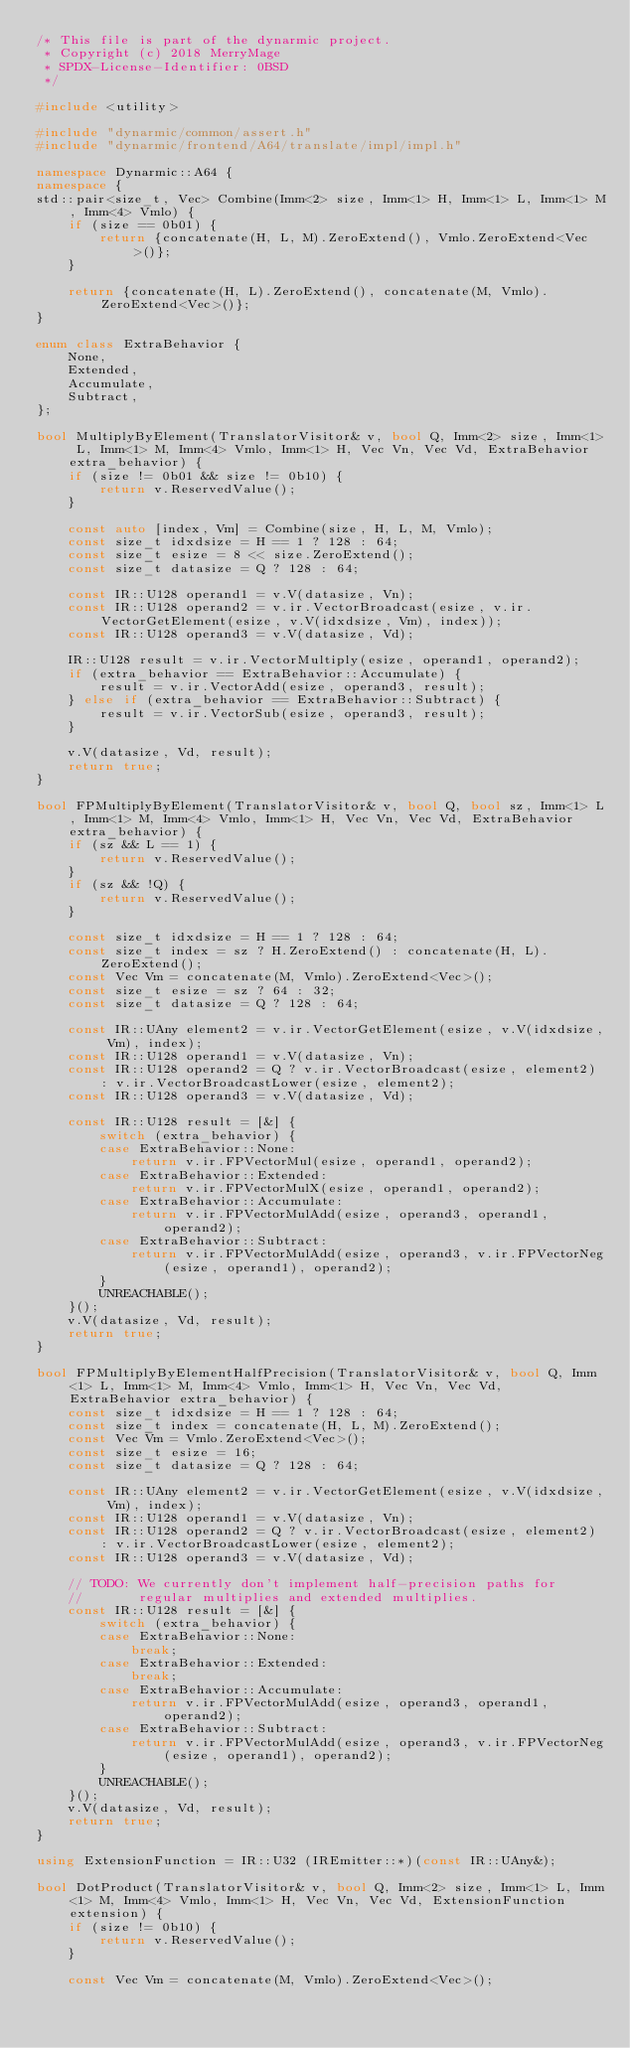Convert code to text. <code><loc_0><loc_0><loc_500><loc_500><_C++_>/* This file is part of the dynarmic project.
 * Copyright (c) 2018 MerryMage
 * SPDX-License-Identifier: 0BSD
 */

#include <utility>

#include "dynarmic/common/assert.h"
#include "dynarmic/frontend/A64/translate/impl/impl.h"

namespace Dynarmic::A64 {
namespace {
std::pair<size_t, Vec> Combine(Imm<2> size, Imm<1> H, Imm<1> L, Imm<1> M, Imm<4> Vmlo) {
    if (size == 0b01) {
        return {concatenate(H, L, M).ZeroExtend(), Vmlo.ZeroExtend<Vec>()};
    }

    return {concatenate(H, L).ZeroExtend(), concatenate(M, Vmlo).ZeroExtend<Vec>()};
}

enum class ExtraBehavior {
    None,
    Extended,
    Accumulate,
    Subtract,
};

bool MultiplyByElement(TranslatorVisitor& v, bool Q, Imm<2> size, Imm<1> L, Imm<1> M, Imm<4> Vmlo, Imm<1> H, Vec Vn, Vec Vd, ExtraBehavior extra_behavior) {
    if (size != 0b01 && size != 0b10) {
        return v.ReservedValue();
    }

    const auto [index, Vm] = Combine(size, H, L, M, Vmlo);
    const size_t idxdsize = H == 1 ? 128 : 64;
    const size_t esize = 8 << size.ZeroExtend();
    const size_t datasize = Q ? 128 : 64;

    const IR::U128 operand1 = v.V(datasize, Vn);
    const IR::U128 operand2 = v.ir.VectorBroadcast(esize, v.ir.VectorGetElement(esize, v.V(idxdsize, Vm), index));
    const IR::U128 operand3 = v.V(datasize, Vd);

    IR::U128 result = v.ir.VectorMultiply(esize, operand1, operand2);
    if (extra_behavior == ExtraBehavior::Accumulate) {
        result = v.ir.VectorAdd(esize, operand3, result);
    } else if (extra_behavior == ExtraBehavior::Subtract) {
        result = v.ir.VectorSub(esize, operand3, result);
    }

    v.V(datasize, Vd, result);
    return true;
}

bool FPMultiplyByElement(TranslatorVisitor& v, bool Q, bool sz, Imm<1> L, Imm<1> M, Imm<4> Vmlo, Imm<1> H, Vec Vn, Vec Vd, ExtraBehavior extra_behavior) {
    if (sz && L == 1) {
        return v.ReservedValue();
    }
    if (sz && !Q) {
        return v.ReservedValue();
    }

    const size_t idxdsize = H == 1 ? 128 : 64;
    const size_t index = sz ? H.ZeroExtend() : concatenate(H, L).ZeroExtend();
    const Vec Vm = concatenate(M, Vmlo).ZeroExtend<Vec>();
    const size_t esize = sz ? 64 : 32;
    const size_t datasize = Q ? 128 : 64;

    const IR::UAny element2 = v.ir.VectorGetElement(esize, v.V(idxdsize, Vm), index);
    const IR::U128 operand1 = v.V(datasize, Vn);
    const IR::U128 operand2 = Q ? v.ir.VectorBroadcast(esize, element2) : v.ir.VectorBroadcastLower(esize, element2);
    const IR::U128 operand3 = v.V(datasize, Vd);

    const IR::U128 result = [&] {
        switch (extra_behavior) {
        case ExtraBehavior::None:
            return v.ir.FPVectorMul(esize, operand1, operand2);
        case ExtraBehavior::Extended:
            return v.ir.FPVectorMulX(esize, operand1, operand2);
        case ExtraBehavior::Accumulate:
            return v.ir.FPVectorMulAdd(esize, operand3, operand1, operand2);
        case ExtraBehavior::Subtract:
            return v.ir.FPVectorMulAdd(esize, operand3, v.ir.FPVectorNeg(esize, operand1), operand2);
        }
        UNREACHABLE();
    }();
    v.V(datasize, Vd, result);
    return true;
}

bool FPMultiplyByElementHalfPrecision(TranslatorVisitor& v, bool Q, Imm<1> L, Imm<1> M, Imm<4> Vmlo, Imm<1> H, Vec Vn, Vec Vd, ExtraBehavior extra_behavior) {
    const size_t idxdsize = H == 1 ? 128 : 64;
    const size_t index = concatenate(H, L, M).ZeroExtend();
    const Vec Vm = Vmlo.ZeroExtend<Vec>();
    const size_t esize = 16;
    const size_t datasize = Q ? 128 : 64;

    const IR::UAny element2 = v.ir.VectorGetElement(esize, v.V(idxdsize, Vm), index);
    const IR::U128 operand1 = v.V(datasize, Vn);
    const IR::U128 operand2 = Q ? v.ir.VectorBroadcast(esize, element2) : v.ir.VectorBroadcastLower(esize, element2);
    const IR::U128 operand3 = v.V(datasize, Vd);

    // TODO: We currently don't implement half-precision paths for
    //       regular multiplies and extended multiplies.
    const IR::U128 result = [&] {
        switch (extra_behavior) {
        case ExtraBehavior::None:
            break;
        case ExtraBehavior::Extended:
            break;
        case ExtraBehavior::Accumulate:
            return v.ir.FPVectorMulAdd(esize, operand3, operand1, operand2);
        case ExtraBehavior::Subtract:
            return v.ir.FPVectorMulAdd(esize, operand3, v.ir.FPVectorNeg(esize, operand1), operand2);
        }
        UNREACHABLE();
    }();
    v.V(datasize, Vd, result);
    return true;
}

using ExtensionFunction = IR::U32 (IREmitter::*)(const IR::UAny&);

bool DotProduct(TranslatorVisitor& v, bool Q, Imm<2> size, Imm<1> L, Imm<1> M, Imm<4> Vmlo, Imm<1> H, Vec Vn, Vec Vd, ExtensionFunction extension) {
    if (size != 0b10) {
        return v.ReservedValue();
    }

    const Vec Vm = concatenate(M, Vmlo).ZeroExtend<Vec>();</code> 